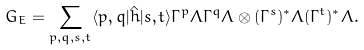<formula> <loc_0><loc_0><loc_500><loc_500>G _ { E } = \sum _ { p , q , s , t } \langle p , q | \hat { h } | s , t \rangle \Gamma ^ { p } \Lambda \Gamma ^ { q } \Lambda \otimes ( \Gamma ^ { s } ) ^ { \ast } \Lambda ( \Gamma ^ { t } ) ^ { \ast } \Lambda .</formula> 